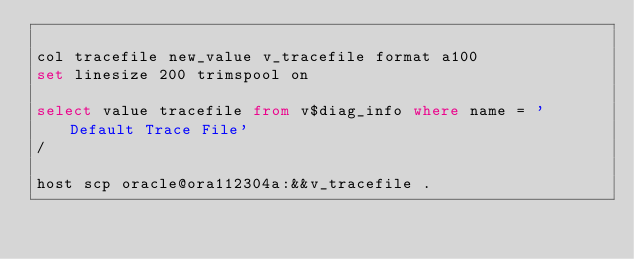Convert code to text. <code><loc_0><loc_0><loc_500><loc_500><_SQL_>
col tracefile new_value v_tracefile format a100
set linesize 200 trimspool on

select value tracefile from v$diag_info where name = 'Default Trace File'
/

host scp oracle@ora112304a:&&v_tracefile .

</code> 